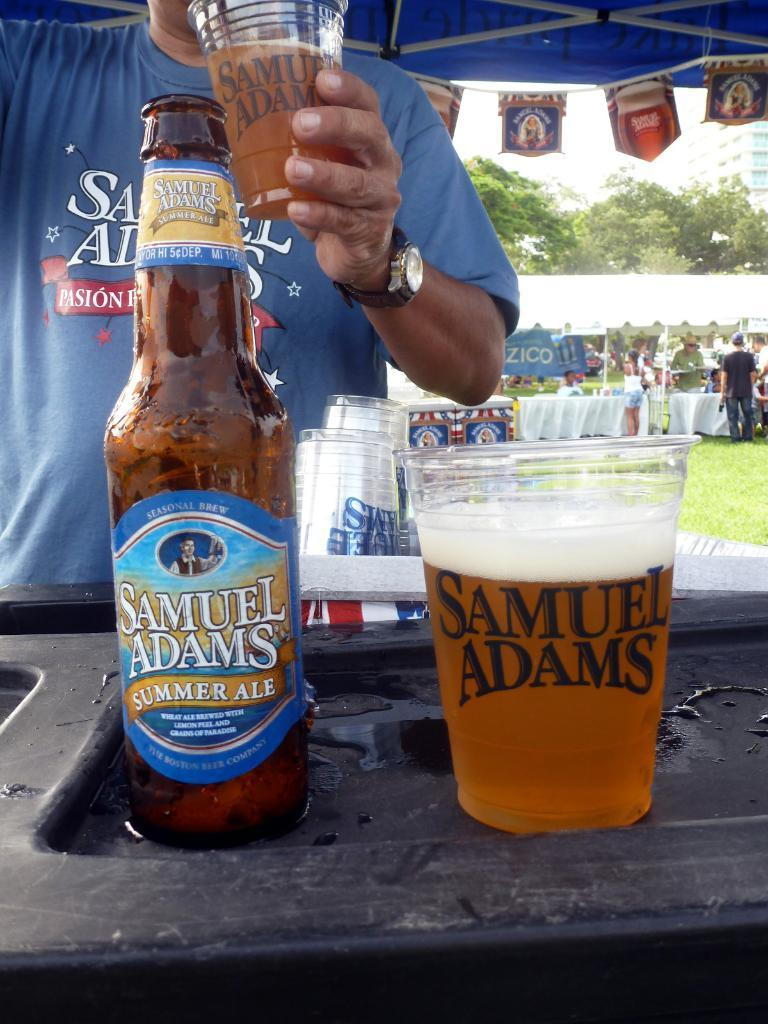<image>
Give a short and clear explanation of the subsequent image. A Samuel Adams summer ale has been poured into a plastic cup at an outdoor festival. 